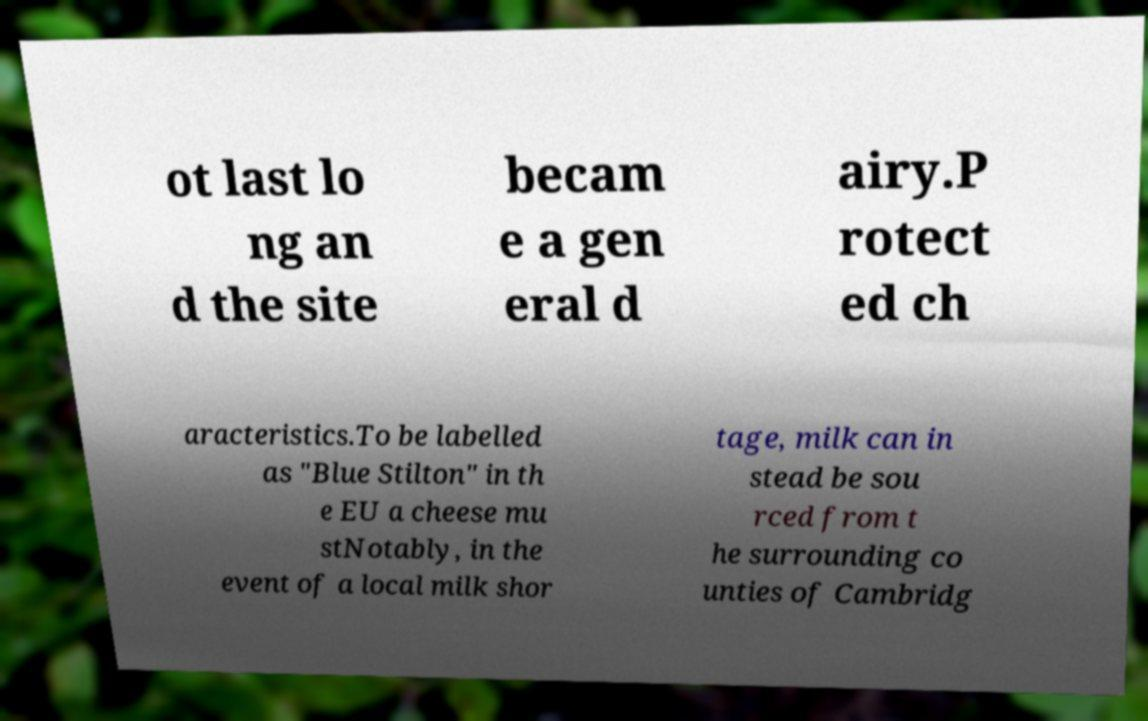Can you accurately transcribe the text from the provided image for me? ot last lo ng an d the site becam e a gen eral d airy.P rotect ed ch aracteristics.To be labelled as "Blue Stilton" in th e EU a cheese mu stNotably, in the event of a local milk shor tage, milk can in stead be sou rced from t he surrounding co unties of Cambridg 